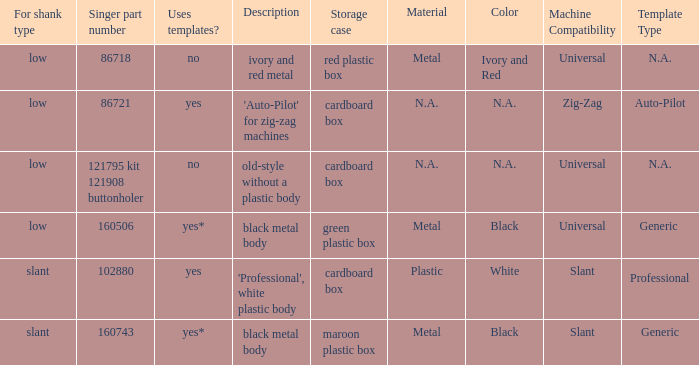What are all the different descriptions for the buttonholer with cardboard box for storage and a low shank type? 'Auto-Pilot' for zig-zag machines, old-style without a plastic body. 